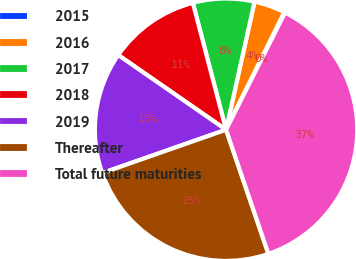Convert chart. <chart><loc_0><loc_0><loc_500><loc_500><pie_chart><fcel>2015<fcel>2016<fcel>2017<fcel>2018<fcel>2019<fcel>Thereafter<fcel>Total future maturities<nl><fcel>0.11%<fcel>3.83%<fcel>7.56%<fcel>11.28%<fcel>15.0%<fcel>24.87%<fcel>37.34%<nl></chart> 